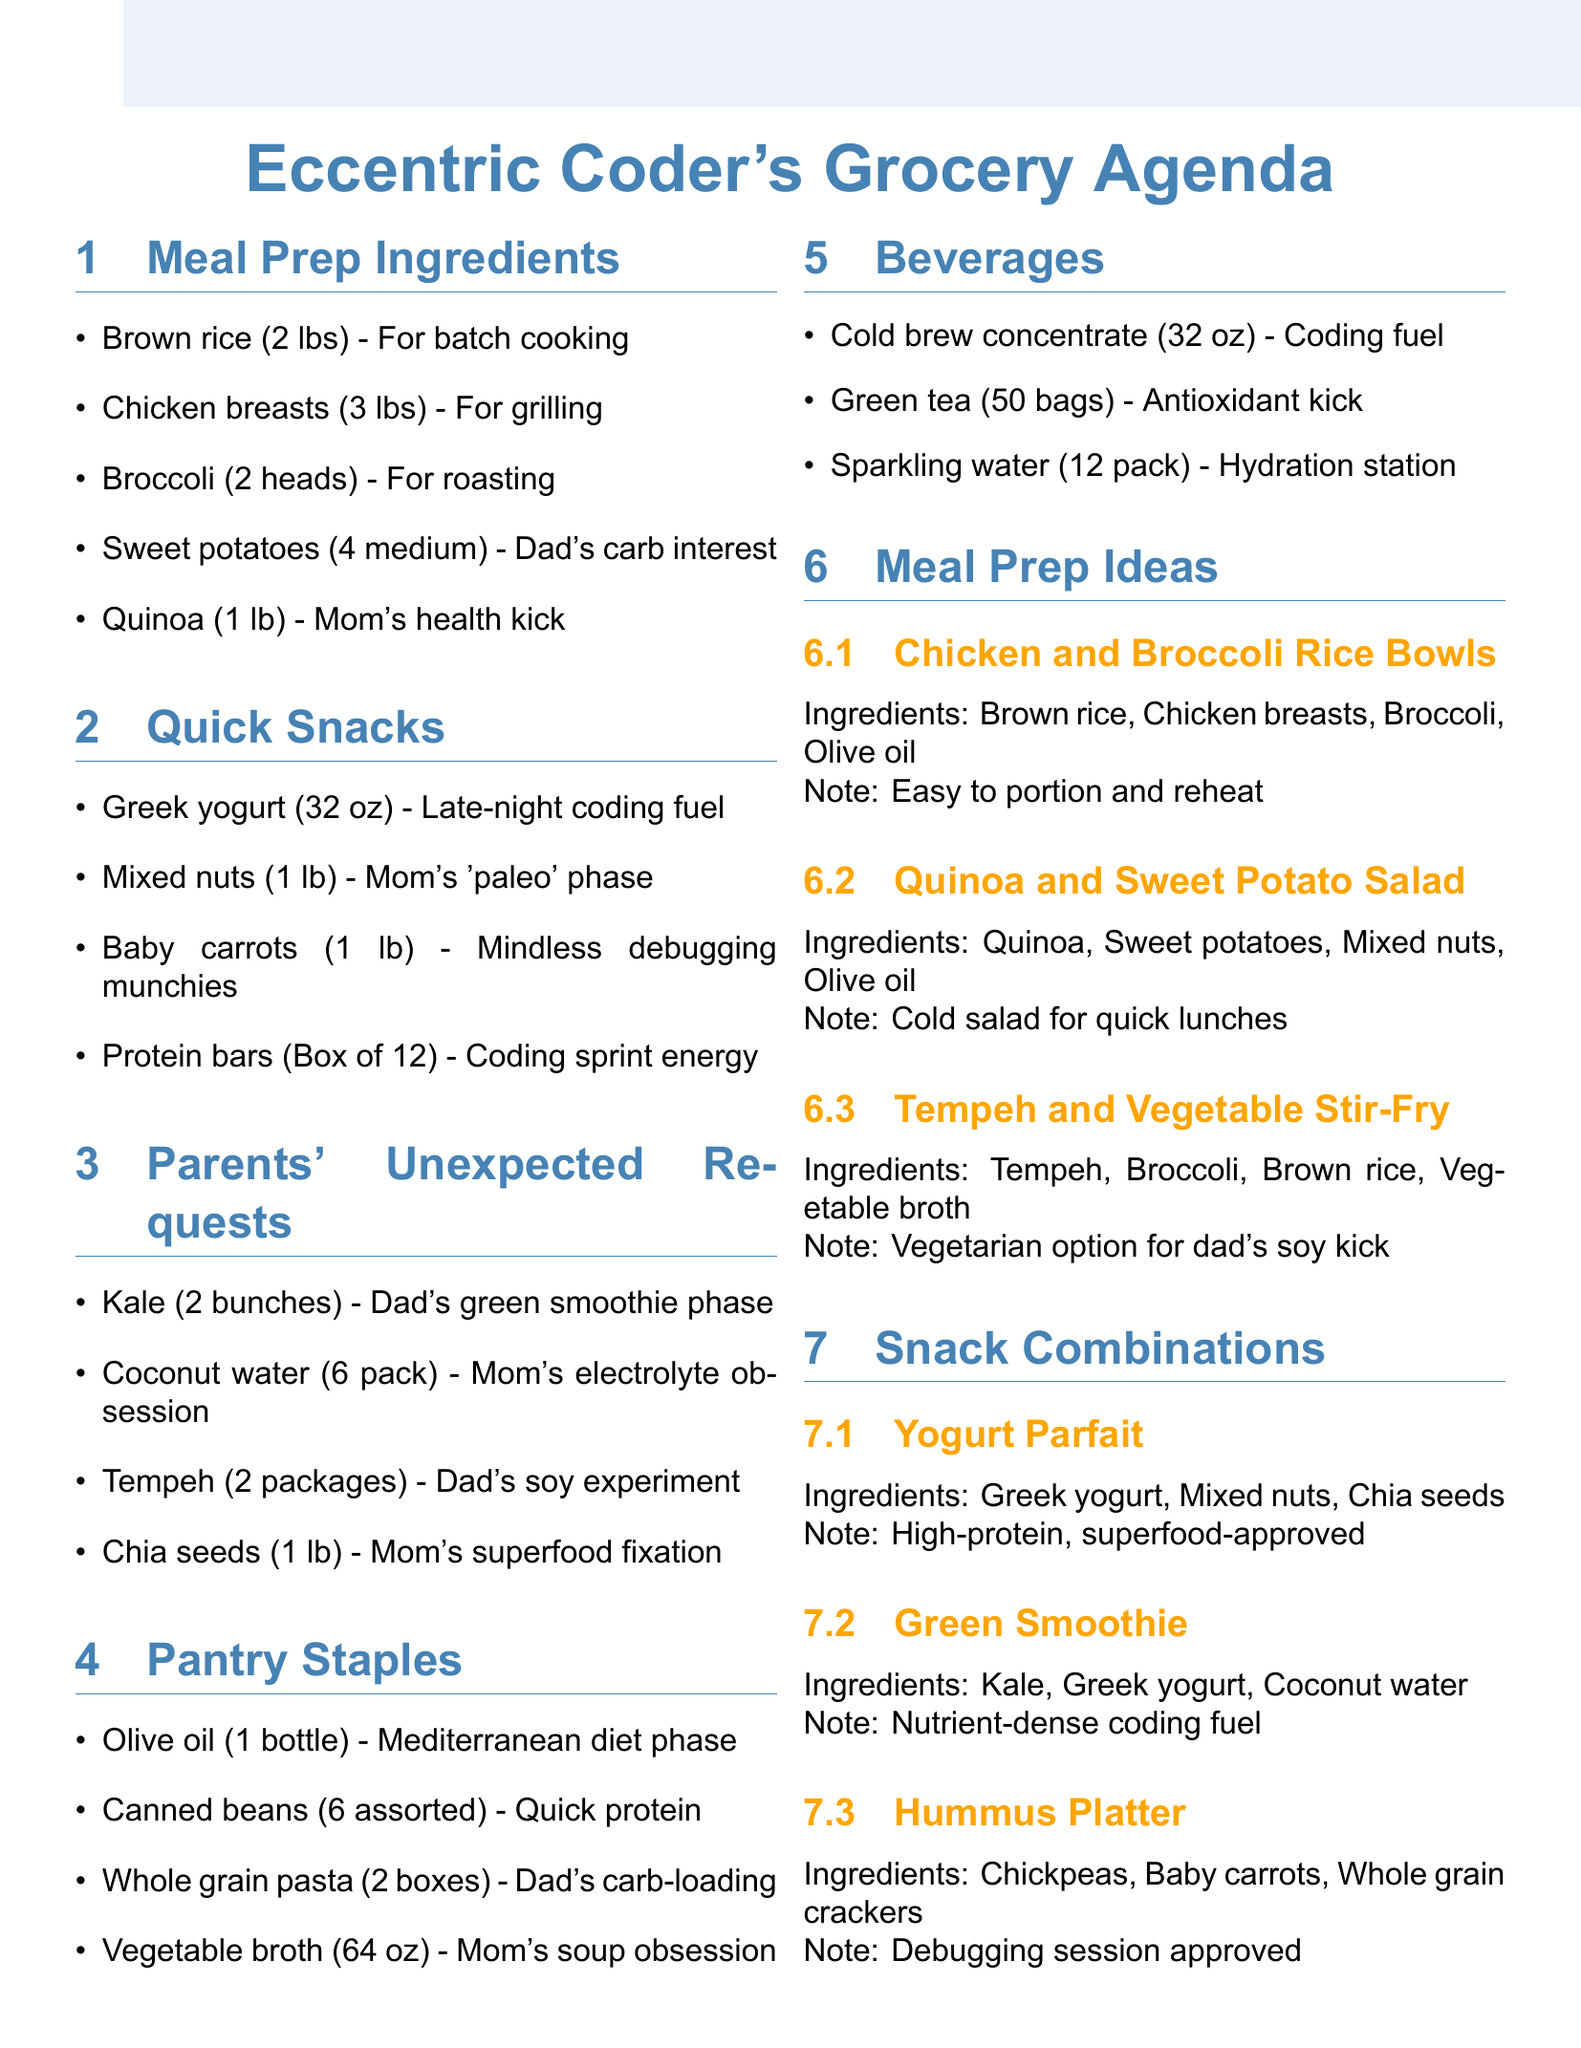What are the meal prep ingredients? The document lists the items under the "Meal Prep Ingredients" section which includes brown rice, chicken breasts, broccoli, sweet potatoes, and quinoa.
Answer: Brown rice, chicken breasts, broccoli, sweet potatoes, quinoa How many packs of coconut water are needed? The document specifies that 6 packs of coconut water are required according to the "Parents' Unexpected Requests" section.
Answer: 6 pack What is the note for sweet potatoes? The note for sweet potatoes explains their purpose in relation to dad's dietary interests, highlighting his sudden interest in complex carbs.
Answer: Dad's sudden interest in complex carbs What snack combination includes whole grain crackers? The "Hummus Platter" under "Snack Combinations" specifies whole grain crackers as one of its ingredients.
Answer: Hummus Platter Which ingredient is mentioned for dad's green smoothie phase? The document indicates that kale is included in the parents' unexpected requests, specifically for dad's green smoothies.
Answer: Kale How many ounces of vegetable broth are listed as a pantry staple? The quantity of low-sodium vegetable broth mentioned is 64 ounces, indicated under the "Pantry Staples" section.
Answer: 64 oz What is a high-protein snack that can be prepared? The document suggests a "Yogurt Parfait," which contains ingredients that are high in protein, as a suitable snack.
Answer: Yogurt Parfait Which meal prep idea uses quinoa? The "Quinoa and Sweet Potato Salad" is identified as a meal prep idea that incorporates quinoa as an ingredient.
Answer: Quinoa and Sweet Potato Salad 